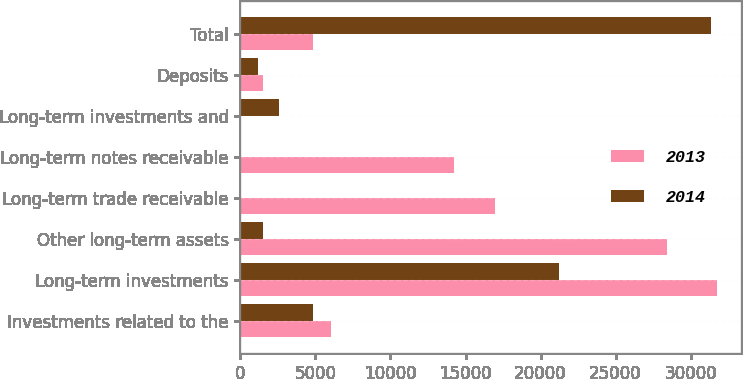Convert chart. <chart><loc_0><loc_0><loc_500><loc_500><stacked_bar_chart><ecel><fcel>Investments related to the<fcel>Long-term investments<fcel>Other long-term assets<fcel>Long-term trade receivable<fcel>Long-term notes receivable<fcel>Long-term investments and<fcel>Deposits<fcel>Total<nl><fcel>2013<fcel>6008<fcel>31759<fcel>28448<fcel>16985<fcel>14231<fcel>0<fcel>1486<fcel>4827<nl><fcel>2014<fcel>4827<fcel>21242<fcel>1522<fcel>0<fcel>0<fcel>2588<fcel>1174<fcel>31353<nl></chart> 